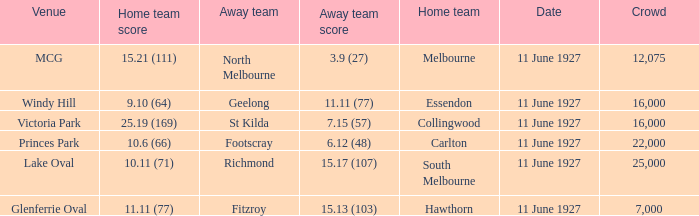What is the sum of all crowds present at the Glenferrie Oval venue? 7000.0. 